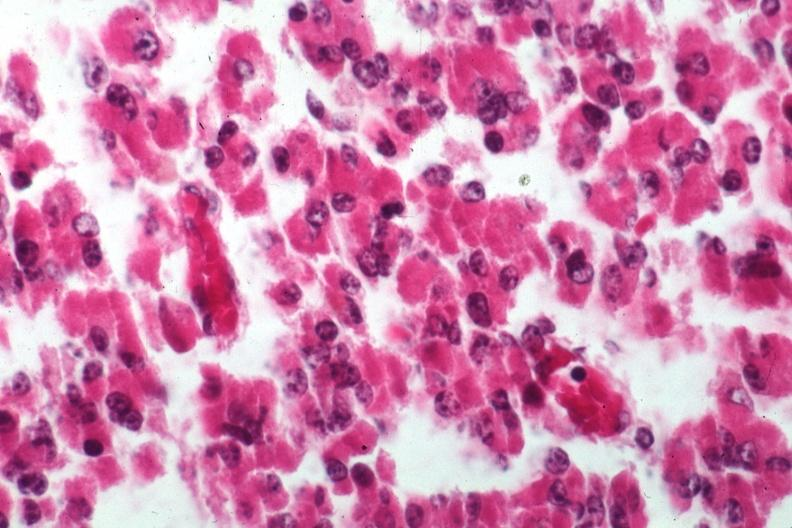s eosinophilic adenoma present?
Answer the question using a single word or phrase. Yes 